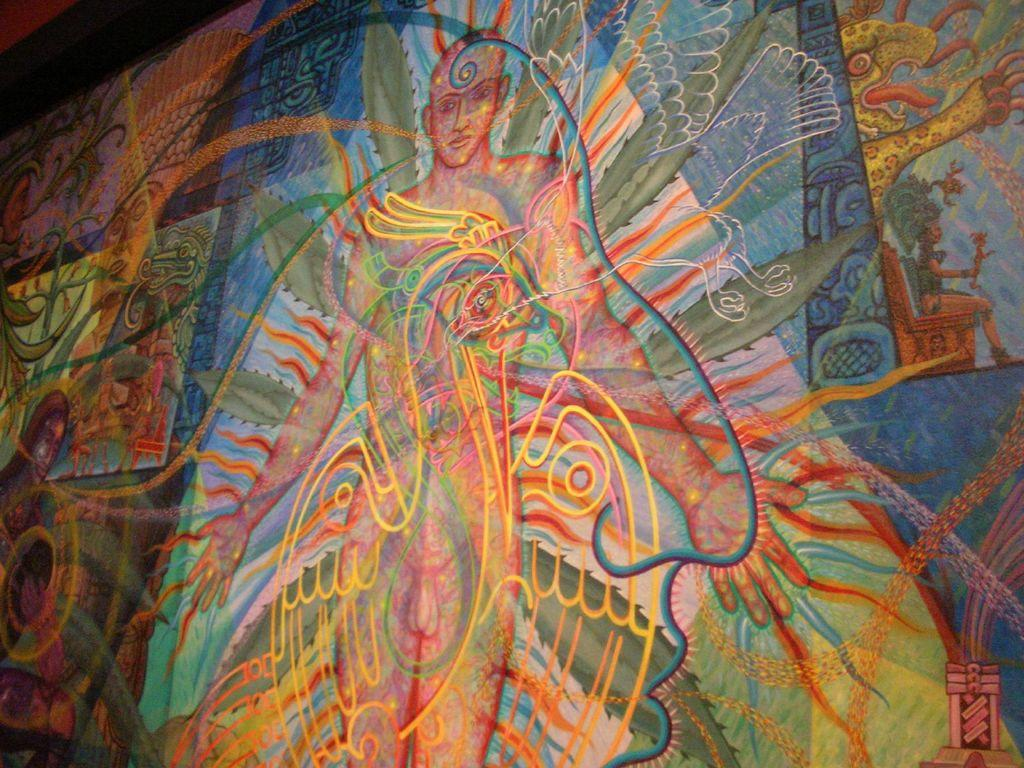What type of artwork is shown in the image? The image is a colorful wall painting. Who or what is depicted in the painting? There is a person and an animal depicted in the painting. What other elements can be seen in the painting? Leaves and a bird are also depicted in the painting. Where can the cat be found in the painting? There is no cat depicted in the painting; it only features a person, an animal, leaves, and a bird. 